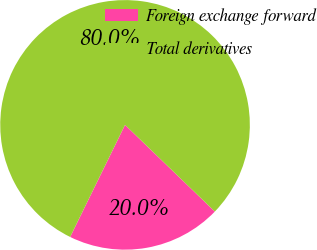<chart> <loc_0><loc_0><loc_500><loc_500><pie_chart><fcel>Foreign exchange forward<fcel>Total derivatives<nl><fcel>20.03%<fcel>79.97%<nl></chart> 